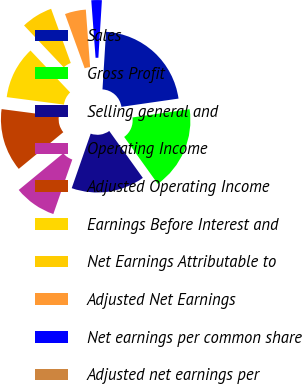Convert chart. <chart><loc_0><loc_0><loc_500><loc_500><pie_chart><fcel>Sales<fcel>Gross Profit<fcel>Selling general and<fcel>Operating Income<fcel>Adjusted Operating Income<fcel>Earnings Before Interest and<fcel>Net Earnings Attributable to<fcel>Adjusted Net Earnings<fcel>Net earnings per common share<fcel>Adjusted net earnings per<nl><fcel>21.74%<fcel>17.39%<fcel>15.22%<fcel>8.7%<fcel>13.04%<fcel>10.87%<fcel>6.52%<fcel>4.35%<fcel>2.17%<fcel>0.0%<nl></chart> 